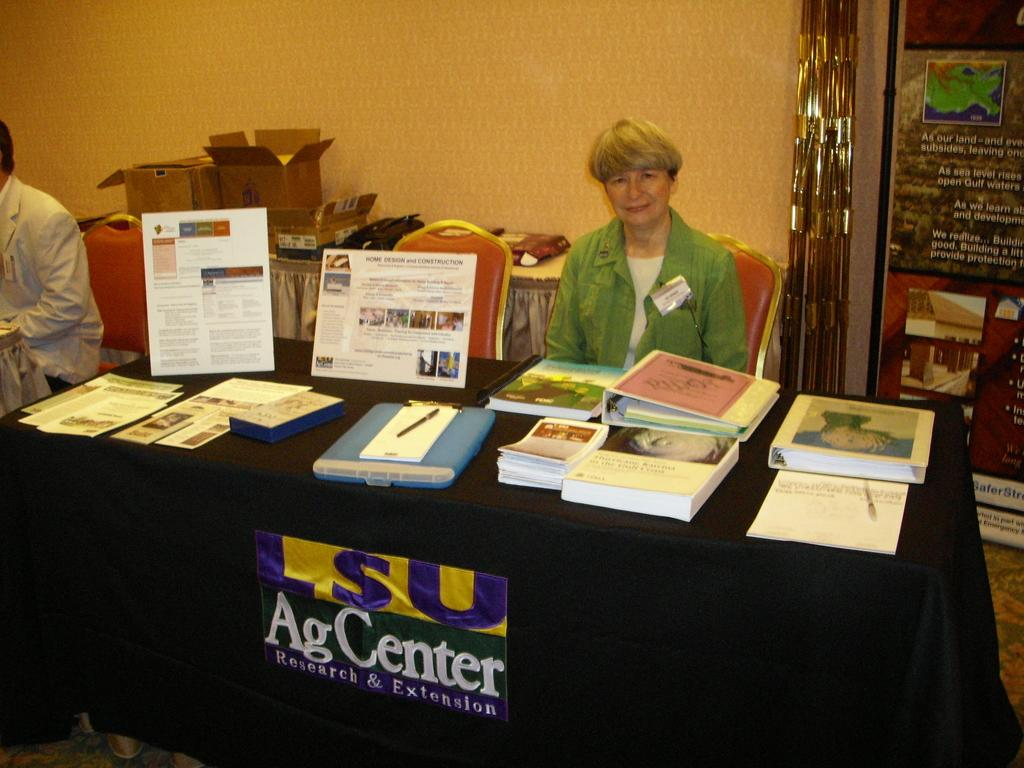<image>
Write a terse but informative summary of the picture. Woman in green behind a table with a sign for AG Center. 